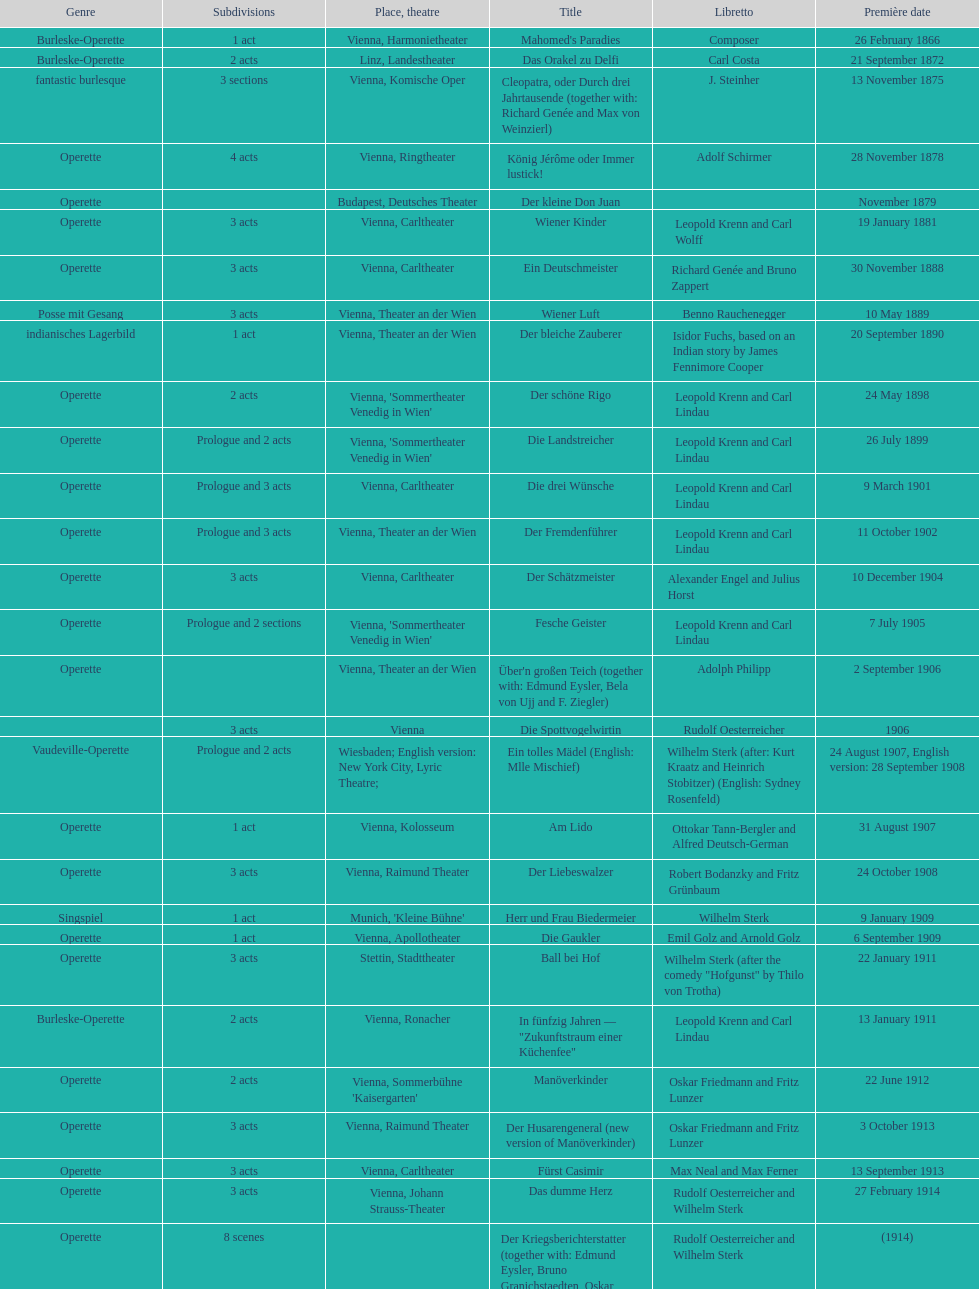Does der liebeswalzer or manöverkinder contain more acts? Der Liebeswalzer. 